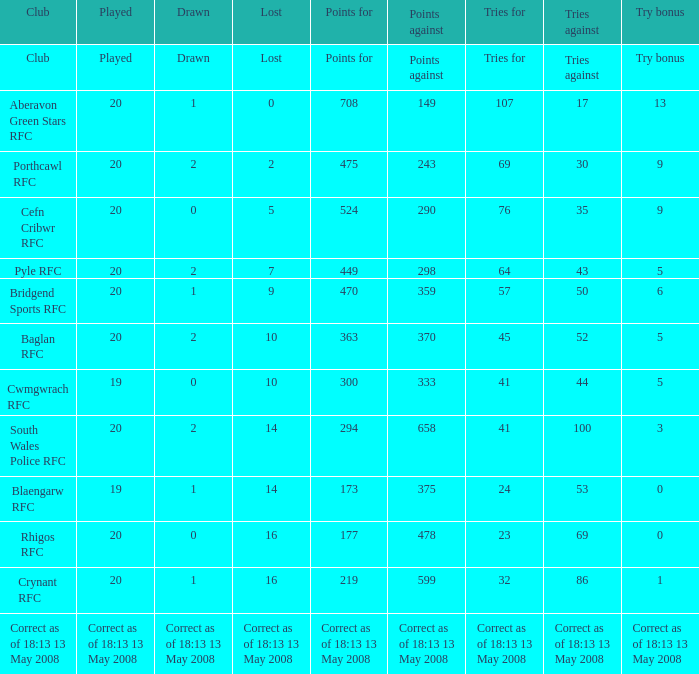What is the points count when 20 games are played with 0 losses? 708.0. 